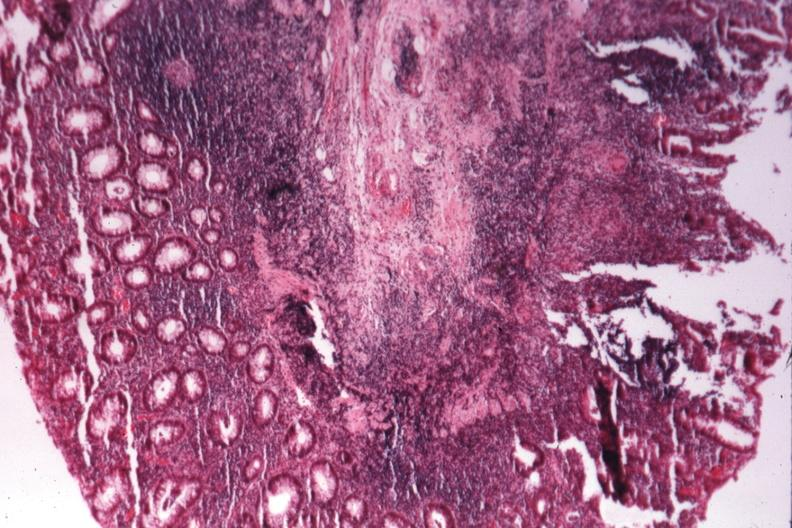what is present?
Answer the question using a single word or phrase. Colon 